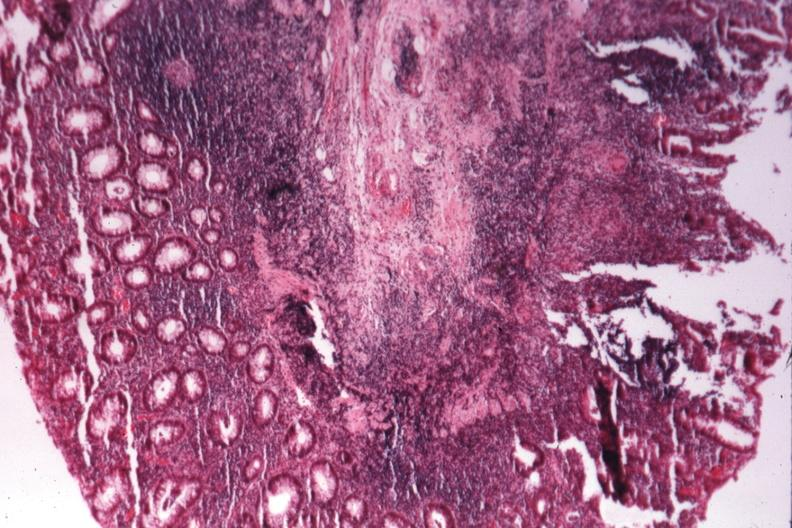what is present?
Answer the question using a single word or phrase. Colon 